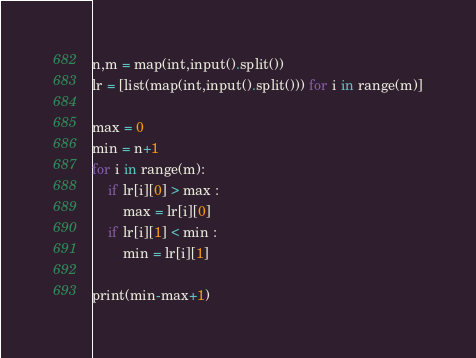<code> <loc_0><loc_0><loc_500><loc_500><_Python_>n,m = map(int,input().split())
lr = [list(map(int,input().split())) for i in range(m)]

max = 0
min = n+1
for i in range(m):
    if lr[i][0] > max :
        max = lr[i][0]
    if lr[i][1] < min :
        min = lr[i][1]

print(min-max+1)
</code> 